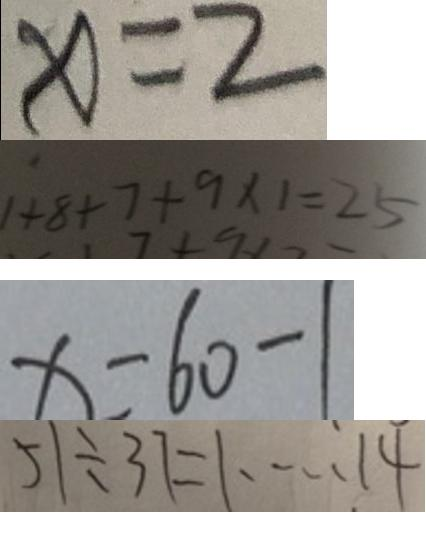Convert formula to latex. <formula><loc_0><loc_0><loc_500><loc_500>x = 2 
 1 + 8 + 7 + 9 \times 1 = 2 5 
 x = 6 0 - 1 
 5 1 \div 3 7 = 1 \cdots 1 4</formula> 